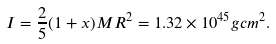<formula> <loc_0><loc_0><loc_500><loc_500>I = \frac { 2 } { 5 } ( 1 + x ) M R ^ { 2 } = 1 . 3 2 \times 1 0 ^ { 4 5 } g c m ^ { 2 } .</formula> 